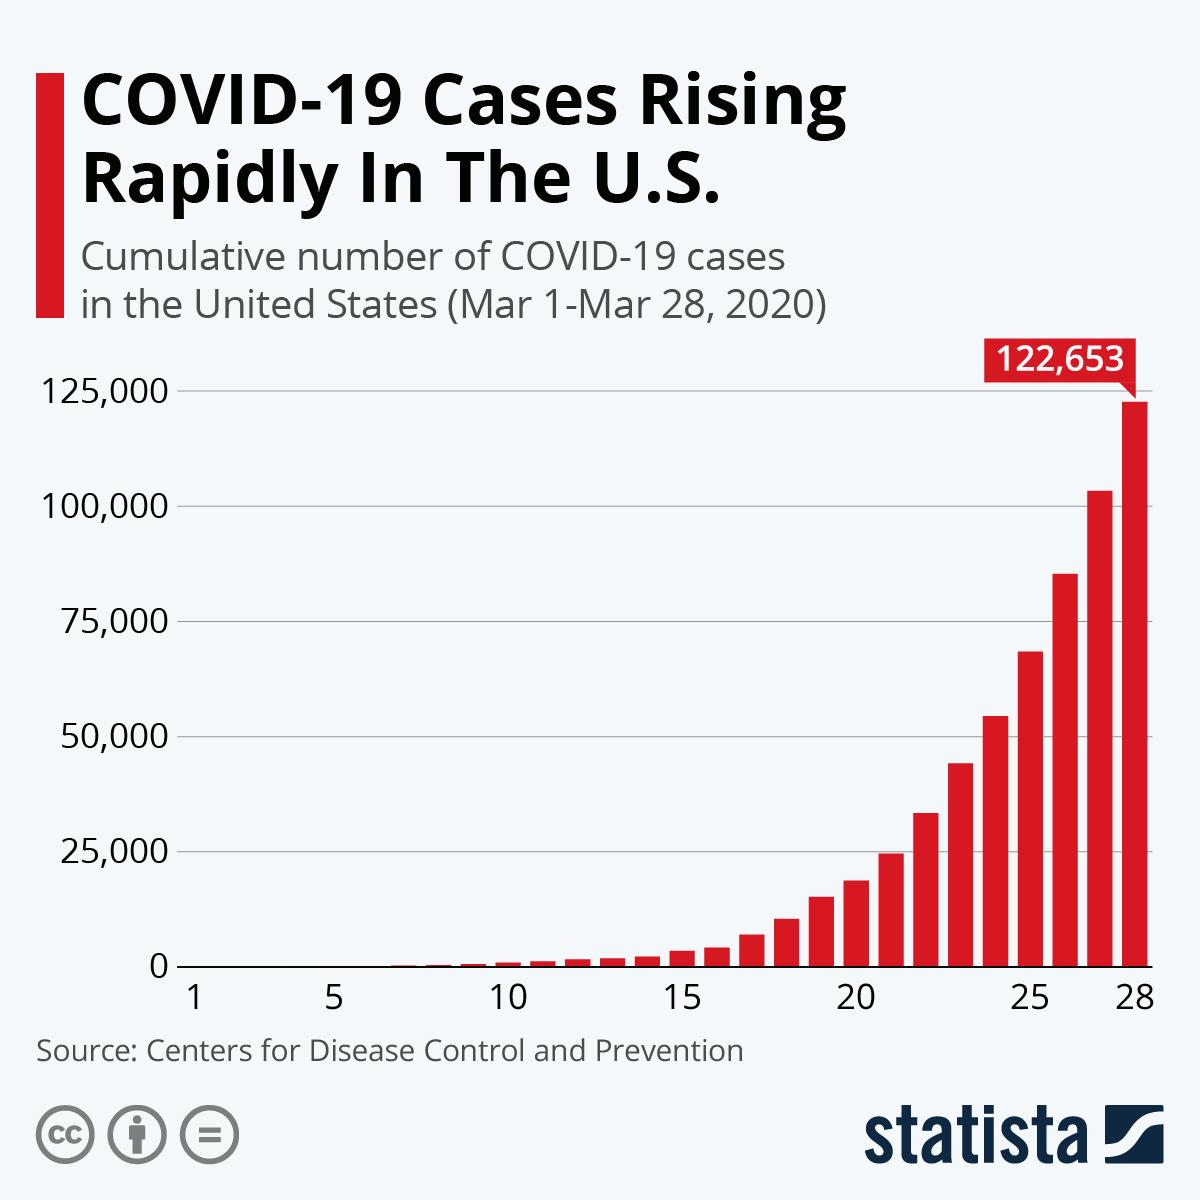Point out several critical features in this image. It took 21 days for COVID-19 cases to reach 25,000. As of March 28, a total of 122,653 cases had been reported. On February 22, COVID-19 cases exceeded 25,000. On February 25, COVID-19 cases surpassed 75,000. 